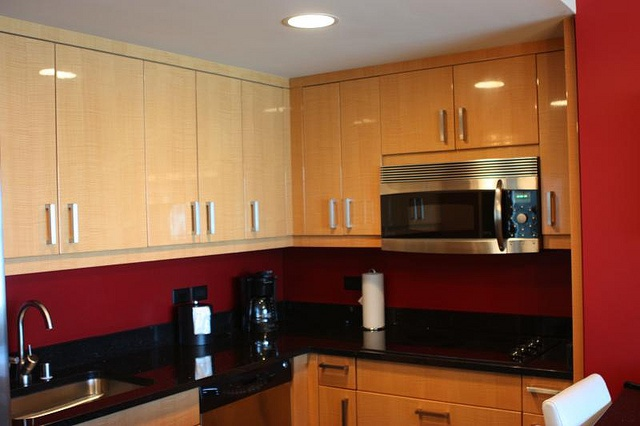Describe the objects in this image and their specific colors. I can see microwave in gray, black, maroon, and tan tones, oven in gray, black, and maroon tones, sink in gray, maroon, and black tones, chair in gray, lightblue, darkgray, and tan tones, and dining table in black, maroon, brown, and gray tones in this image. 